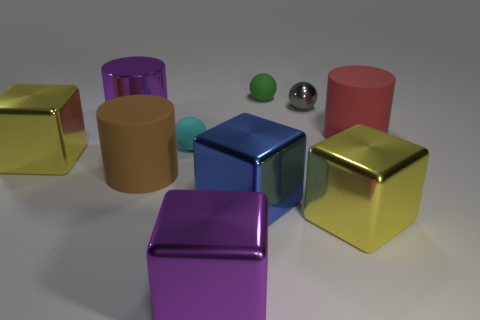Considering the lighting in the image, where might the light source be located? The light source seems to be positioned above the objects, slightly to the right from the viewer's perspective. This is indicated by the highlights and shadows visible on the objects, particularly the reflections on the metal cubes, and the shadow they cast on the ground. 